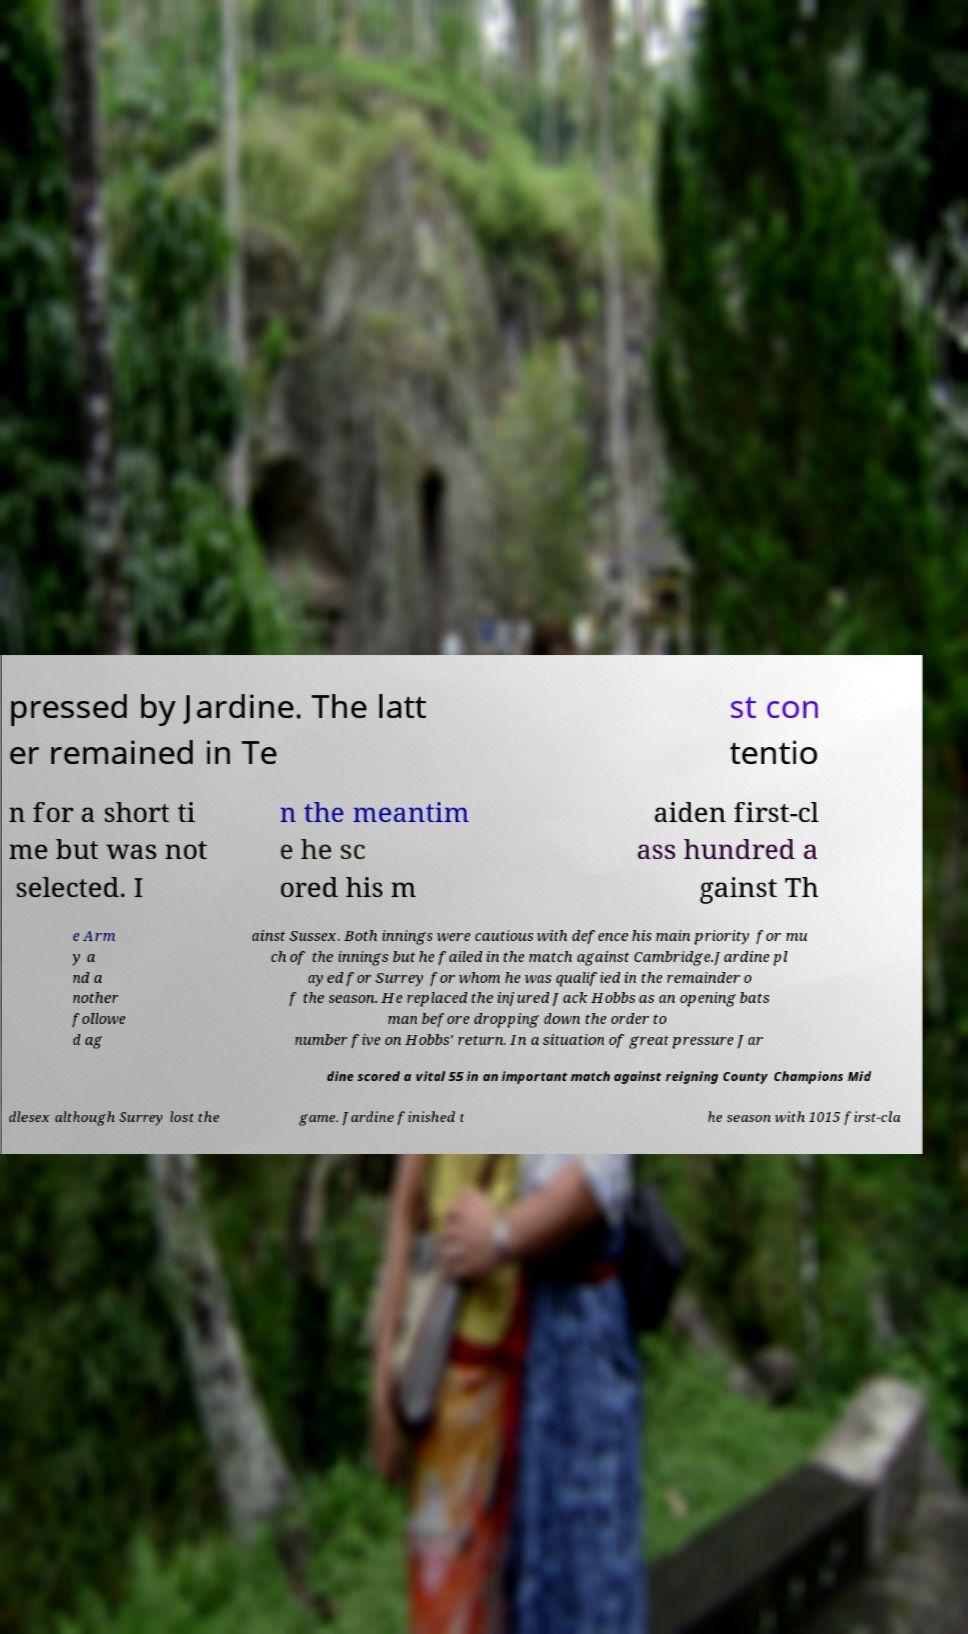Could you assist in decoding the text presented in this image and type it out clearly? pressed by Jardine. The latt er remained in Te st con tentio n for a short ti me but was not selected. I n the meantim e he sc ored his m aiden first-cl ass hundred a gainst Th e Arm y a nd a nother followe d ag ainst Sussex. Both innings were cautious with defence his main priority for mu ch of the innings but he failed in the match against Cambridge.Jardine pl ayed for Surrey for whom he was qualified in the remainder o f the season. He replaced the injured Jack Hobbs as an opening bats man before dropping down the order to number five on Hobbs' return. In a situation of great pressure Jar dine scored a vital 55 in an important match against reigning County Champions Mid dlesex although Surrey lost the game. Jardine finished t he season with 1015 first-cla 